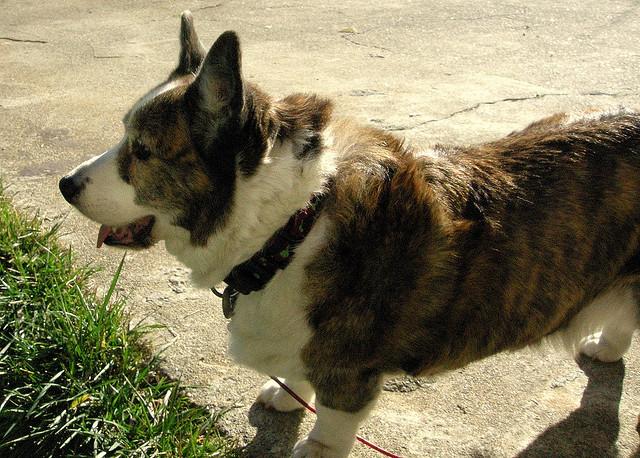Is the dog panting?
Quick response, please. Yes. What is the dog looking at?
Quick response, please. Grass. Is it a cat?
Short answer required. No. 